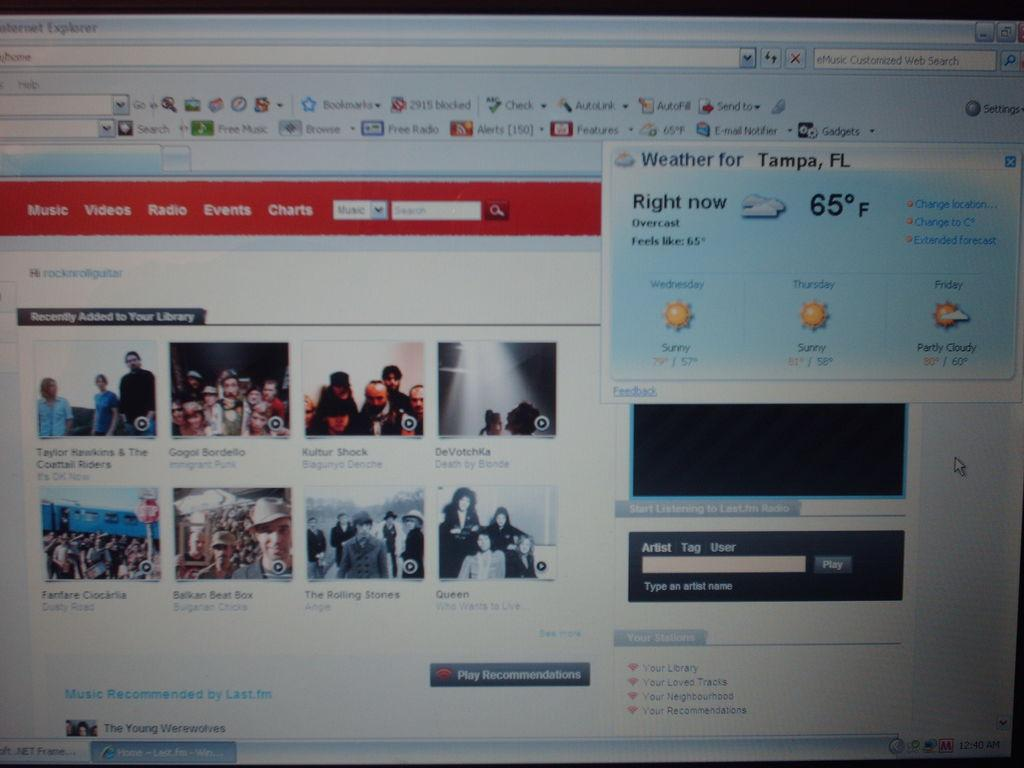<image>
Render a clear and concise summary of the photo. Computer screen showing the weather for Tampa at 65. 